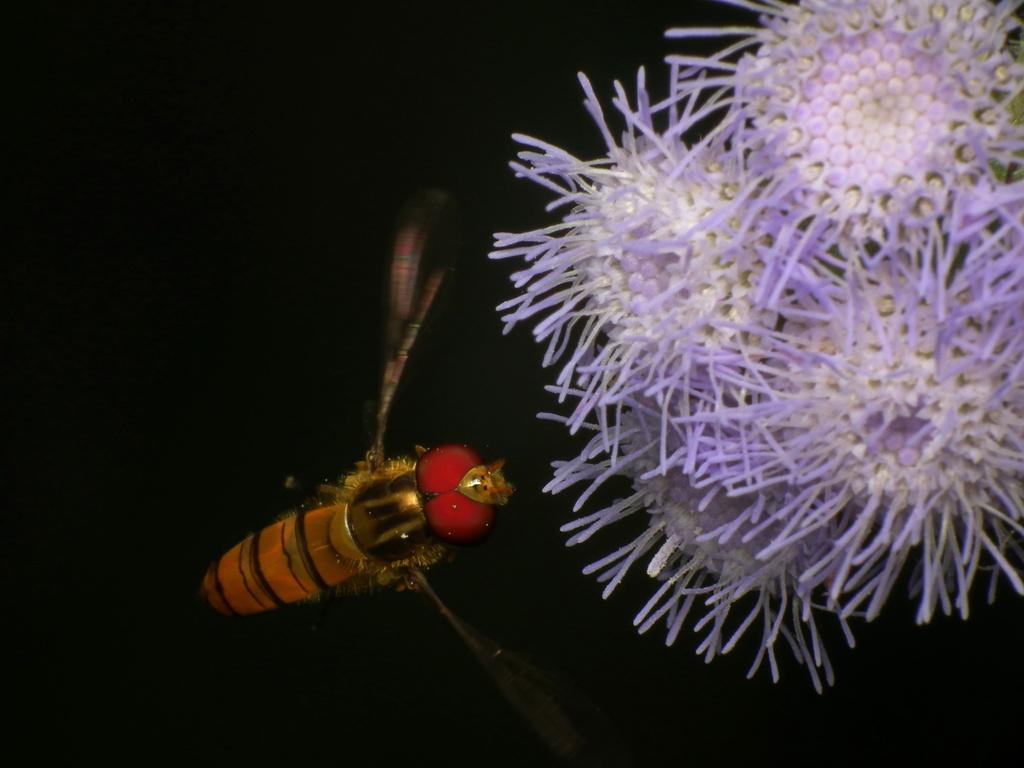Can you describe this image briefly? In this picture we can see an insect and flowers and in the background we can see it is dark. 